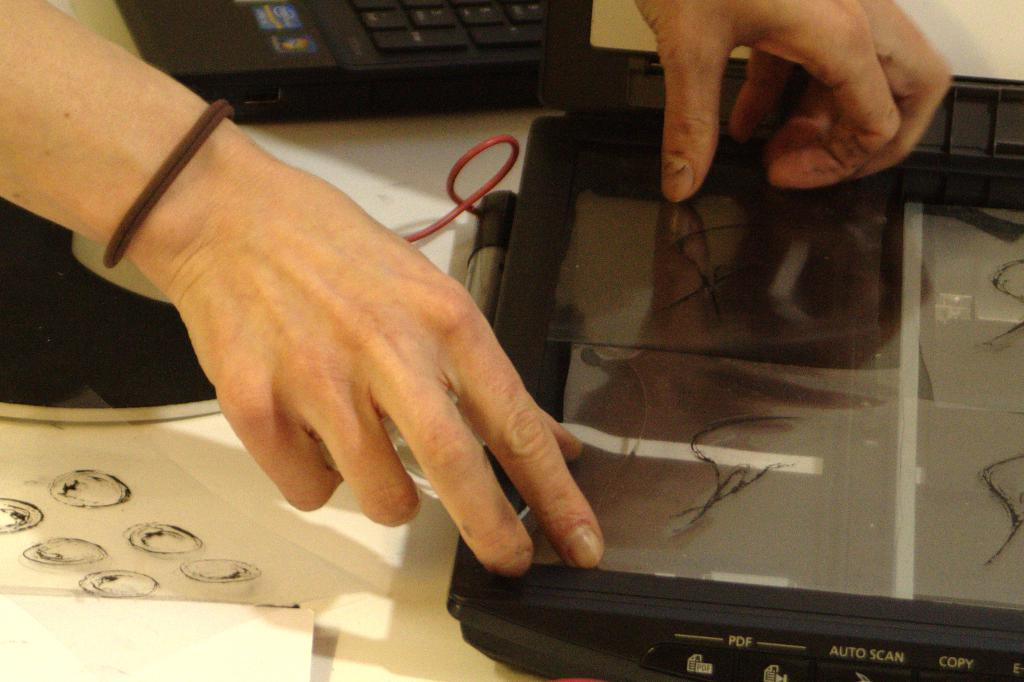What piece of furniture is present in the image? There is a table in the image. What is placed on the table? There is a laptop and other electronic gadgets on the table. Can you describe any body parts visible in the image? A person's hand is visible in the image. What type of belief is represented by the quince on the table? There is no quince present in the image, so it is not possible to determine any beliefs represented by it. 